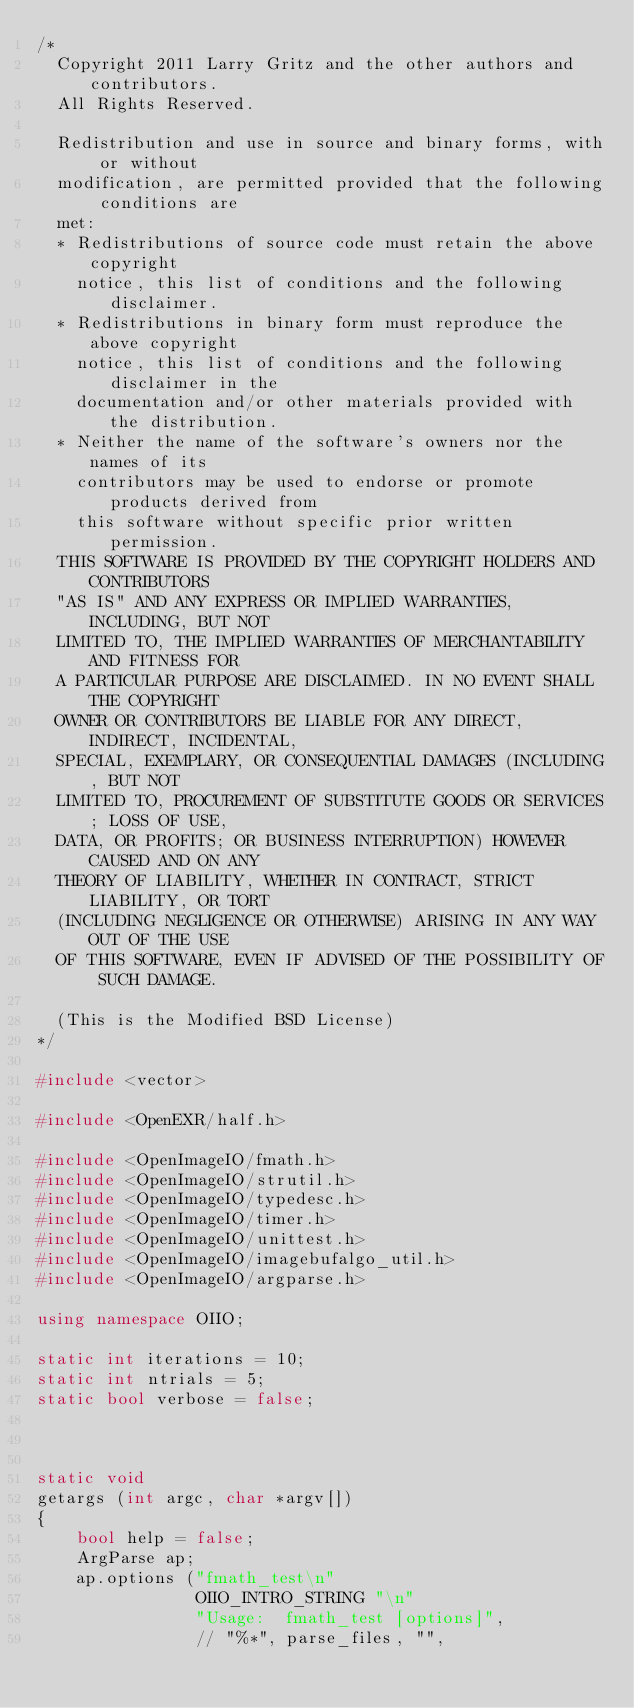<code> <loc_0><loc_0><loc_500><loc_500><_C++_>/*
  Copyright 2011 Larry Gritz and the other authors and contributors.
  All Rights Reserved.

  Redistribution and use in source and binary forms, with or without
  modification, are permitted provided that the following conditions are
  met:
  * Redistributions of source code must retain the above copyright
    notice, this list of conditions and the following disclaimer.
  * Redistributions in binary form must reproduce the above copyright
    notice, this list of conditions and the following disclaimer in the
    documentation and/or other materials provided with the distribution.
  * Neither the name of the software's owners nor the names of its
    contributors may be used to endorse or promote products derived from
    this software without specific prior written permission.
  THIS SOFTWARE IS PROVIDED BY THE COPYRIGHT HOLDERS AND CONTRIBUTORS
  "AS IS" AND ANY EXPRESS OR IMPLIED WARRANTIES, INCLUDING, BUT NOT
  LIMITED TO, THE IMPLIED WARRANTIES OF MERCHANTABILITY AND FITNESS FOR
  A PARTICULAR PURPOSE ARE DISCLAIMED. IN NO EVENT SHALL THE COPYRIGHT
  OWNER OR CONTRIBUTORS BE LIABLE FOR ANY DIRECT, INDIRECT, INCIDENTAL,
  SPECIAL, EXEMPLARY, OR CONSEQUENTIAL DAMAGES (INCLUDING, BUT NOT
  LIMITED TO, PROCUREMENT OF SUBSTITUTE GOODS OR SERVICES; LOSS OF USE,
  DATA, OR PROFITS; OR BUSINESS INTERRUPTION) HOWEVER CAUSED AND ON ANY
  THEORY OF LIABILITY, WHETHER IN CONTRACT, STRICT LIABILITY, OR TORT
  (INCLUDING NEGLIGENCE OR OTHERWISE) ARISING IN ANY WAY OUT OF THE USE
  OF THIS SOFTWARE, EVEN IF ADVISED OF THE POSSIBILITY OF SUCH DAMAGE.

  (This is the Modified BSD License)
*/

#include <vector>

#include <OpenEXR/half.h>

#include <OpenImageIO/fmath.h>
#include <OpenImageIO/strutil.h>
#include <OpenImageIO/typedesc.h>
#include <OpenImageIO/timer.h>
#include <OpenImageIO/unittest.h>
#include <OpenImageIO/imagebufalgo_util.h>
#include <OpenImageIO/argparse.h>

using namespace OIIO;

static int iterations = 10;
static int ntrials = 5;
static bool verbose = false;



static void
getargs (int argc, char *argv[])
{
    bool help = false;
    ArgParse ap;
    ap.options ("fmath_test\n"
                OIIO_INTRO_STRING "\n"
                "Usage:  fmath_test [options]",
                // "%*", parse_files, "",</code> 